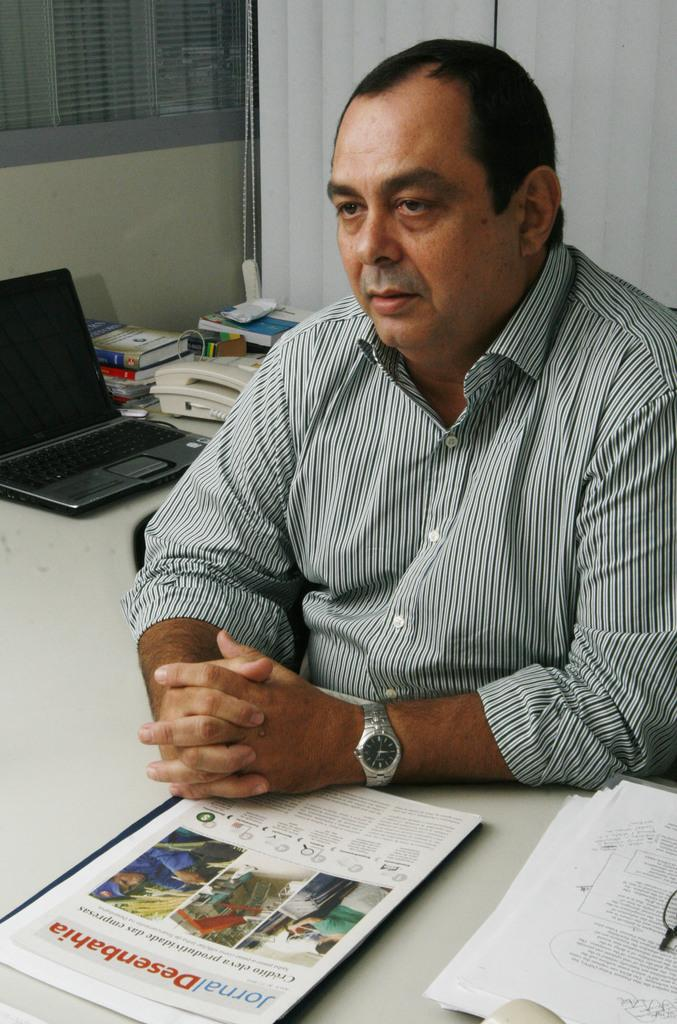<image>
Present a compact description of the photo's key features. A man in a striped dress shirt sits at his desk next to a laptop, phone, books, and a pamphlet titled directly "Desenbahia" in front of him. 